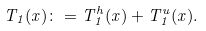Convert formula to latex. <formula><loc_0><loc_0><loc_500><loc_500>T _ { 1 } ( x ) \colon = T _ { 1 } ^ { h } ( x ) + T _ { 1 } ^ { u } ( x ) .</formula> 